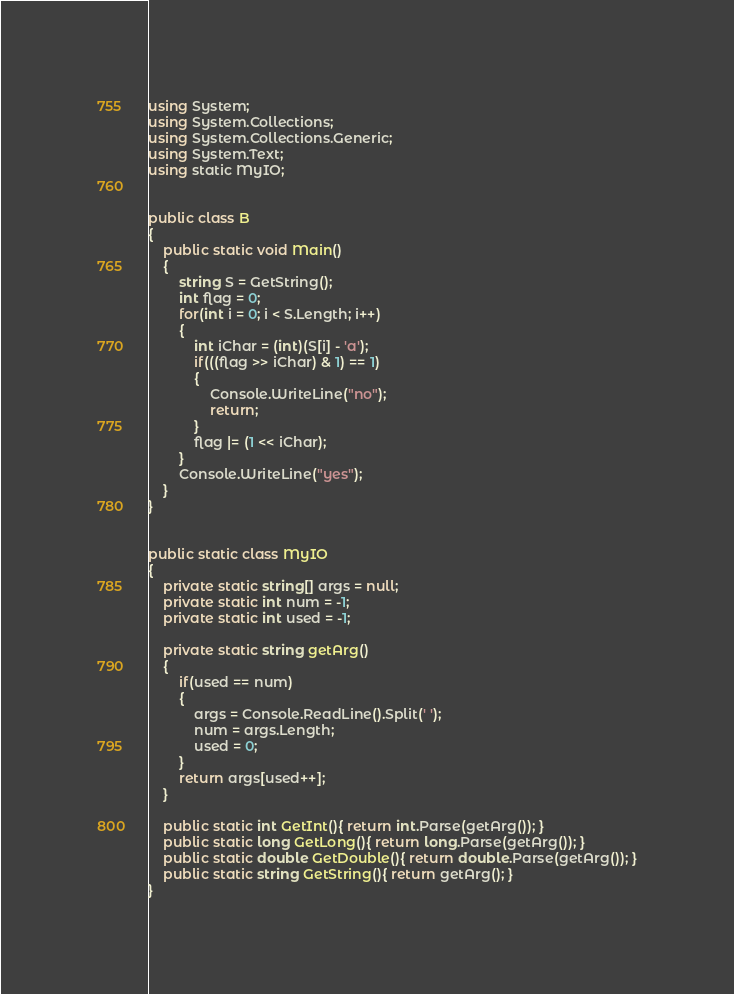<code> <loc_0><loc_0><loc_500><loc_500><_C#_>using System;
using System.Collections;
using System.Collections.Generic;
using System.Text;
using static MyIO;


public class B
{
	public static void Main()	
	{
		string S = GetString();
		int flag = 0;
		for(int i = 0; i < S.Length; i++)
		{
			int iChar = (int)(S[i] - 'a');
			if(((flag >> iChar) & 1) == 1)
			{
				Console.WriteLine("no");
				return;
			}
			flag |= (1 << iChar);
		}
		Console.WriteLine("yes");
	}
}


public static class MyIO
{
	private static string[] args = null;
	private static int num = -1;
	private static int used = -1;

	private static string getArg()
	{
		if(used == num)
		{
			args = Console.ReadLine().Split(' ');
			num = args.Length;
			used = 0;
		}
		return args[used++];
	}

	public static int GetInt(){ return int.Parse(getArg()); }
	public static long GetLong(){ return long.Parse(getArg()); }
	public static double GetDouble(){ return double.Parse(getArg()); }
	public static string GetString(){ return getArg(); }
}
</code> 